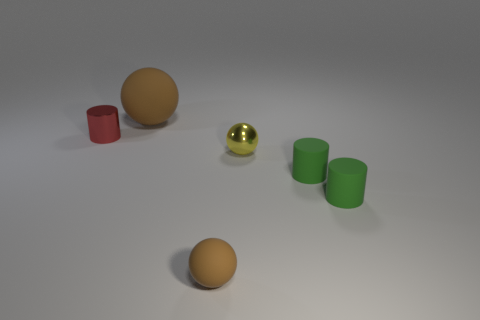Subtract all small green rubber cylinders. How many cylinders are left? 1 Subtract all yellow spheres. How many spheres are left? 2 Subtract 1 balls. How many balls are left? 2 Add 1 red metal balls. How many objects exist? 7 Subtract 0 yellow cylinders. How many objects are left? 6 Subtract all purple balls. Subtract all purple cylinders. How many balls are left? 3 Subtract all blue cubes. How many yellow cylinders are left? 0 Subtract all tiny matte balls. Subtract all big yellow cubes. How many objects are left? 5 Add 1 tiny brown rubber balls. How many tiny brown rubber balls are left? 2 Add 1 small red metal balls. How many small red metal balls exist? 1 